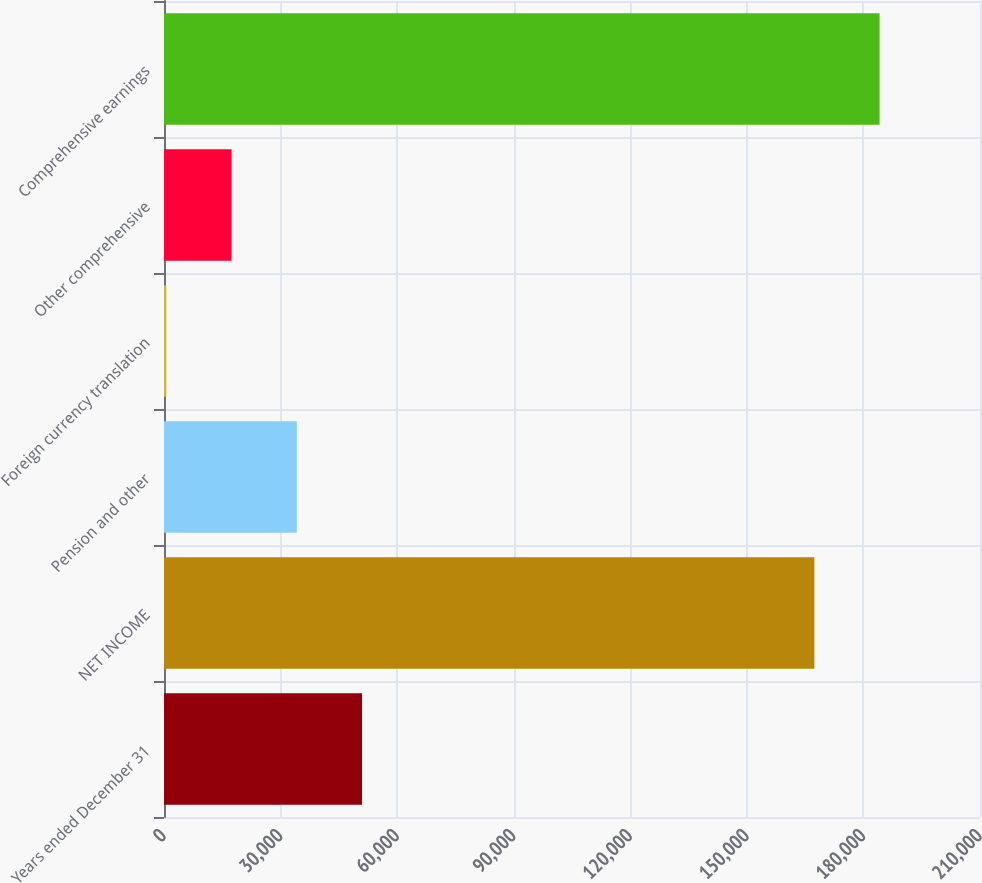Convert chart to OTSL. <chart><loc_0><loc_0><loc_500><loc_500><bar_chart><fcel>Years ended December 31<fcel>NET INCOME<fcel>Pension and other<fcel>Foreign currency translation<fcel>Other comprehensive<fcel>Comprehensive earnings<nl><fcel>50963<fcel>167369<fcel>34176<fcel>602<fcel>17389<fcel>184156<nl></chart> 